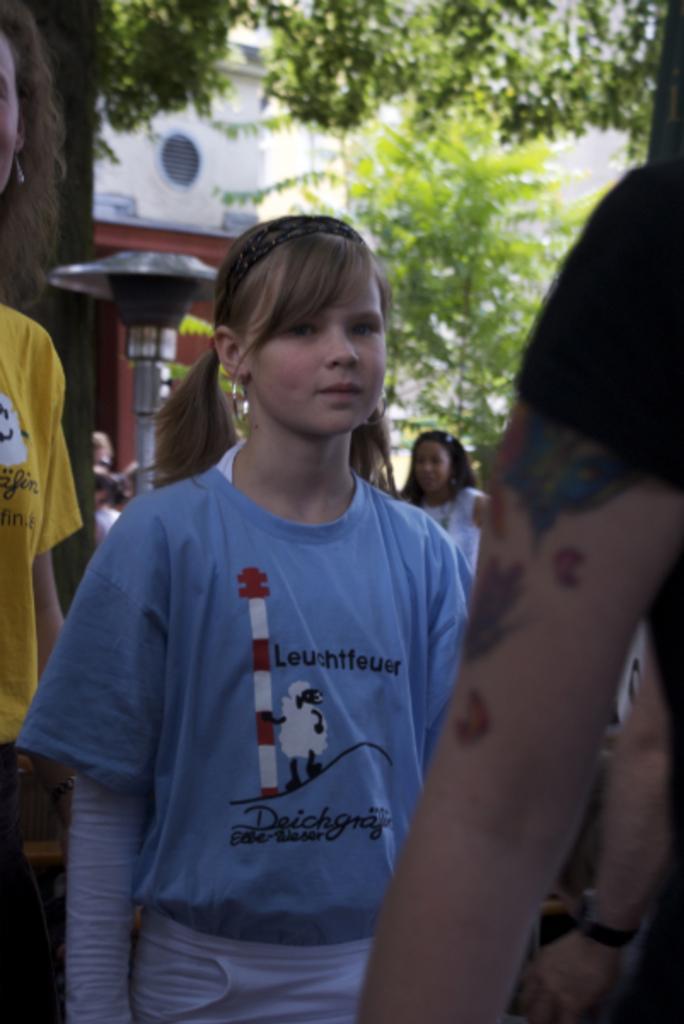Could you give a brief overview of what you see in this image? In front of the image there is a person´s hand, behind the hand, there is a girl standing, behind the girl, there are a few other people, behind them there is a lamp post, trees and a building. 